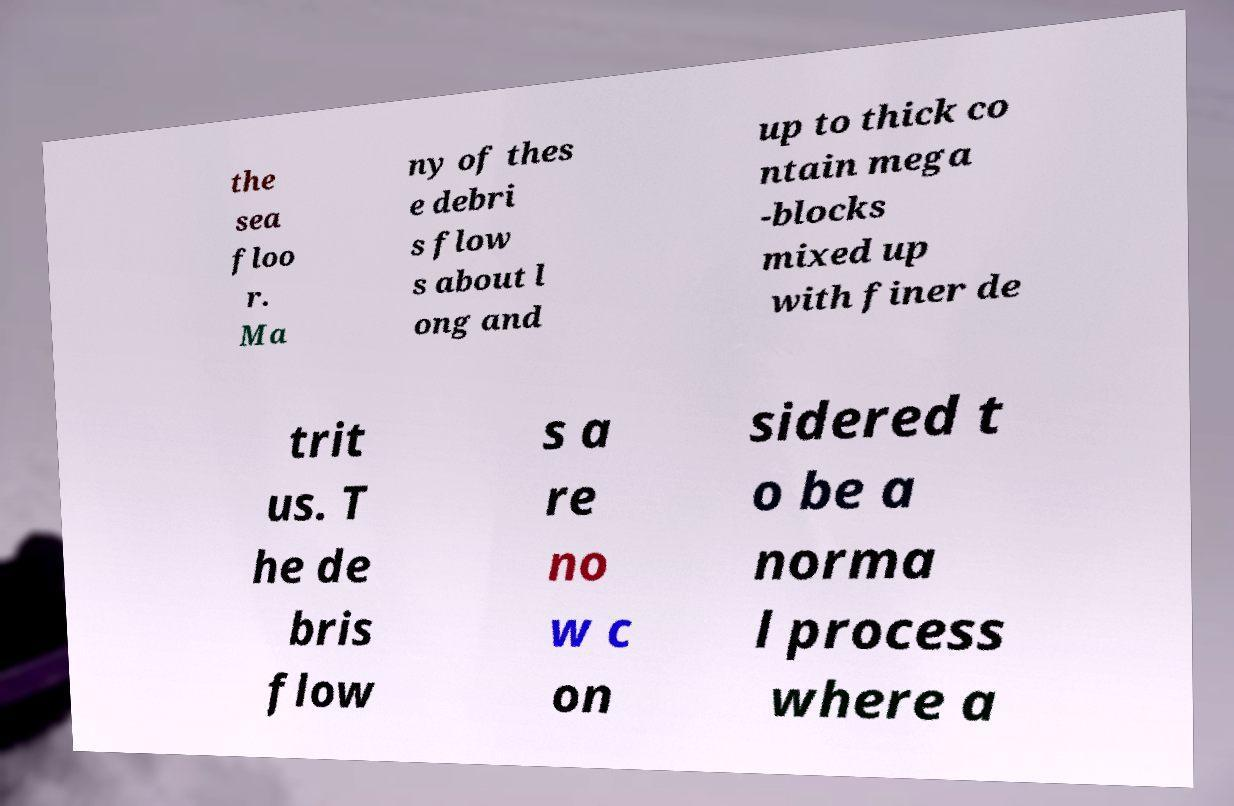Can you accurately transcribe the text from the provided image for me? the sea floo r. Ma ny of thes e debri s flow s about l ong and up to thick co ntain mega -blocks mixed up with finer de trit us. T he de bris flow s a re no w c on sidered t o be a norma l process where a 